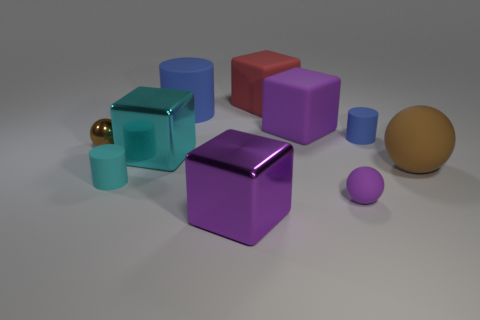What colors are the objects in the image? The objects in the image come in various colors including blue, red, purple, and gold, creating a visually interesting assortment. 